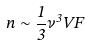<formula> <loc_0><loc_0><loc_500><loc_500>n \sim \frac { 1 } { 3 } \nu ^ { 3 } V F</formula> 